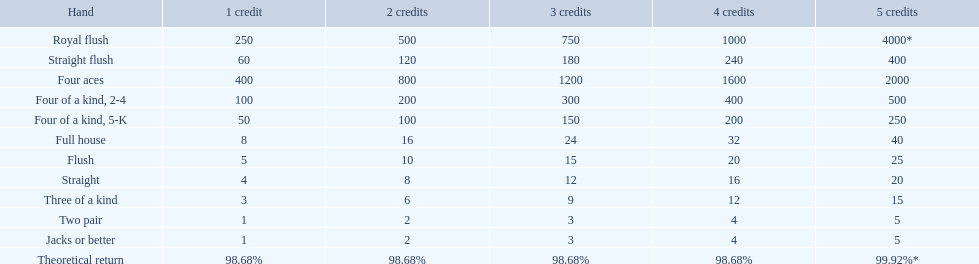What do the hands refer to? Royal flush, Straight flush, Four aces, Four of a kind, 2-4, Four of a kind, 5-K, Full house, Flush, Straight, Three of a kind, Two pair, Jacks or better. Which one is positioned above the other? Royal flush. 